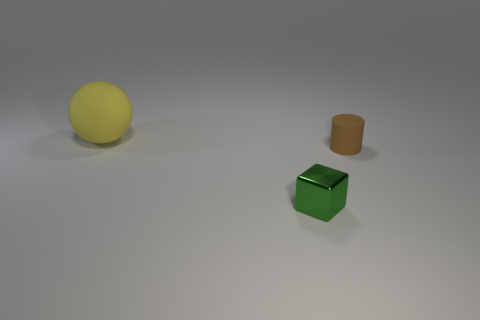Is there any other thing that has the same shape as the tiny matte object?
Give a very brief answer. No. There is a matte object to the right of the green object; how big is it?
Provide a short and direct response. Small. The thing in front of the tiny object behind the small object that is to the left of the tiny brown object is made of what material?
Ensure brevity in your answer.  Metal. Is there a metal cube of the same size as the cylinder?
Make the answer very short. Yes. There is a brown cylinder that is the same size as the metal object; what is it made of?
Provide a succinct answer. Rubber. There is a rubber thing that is right of the yellow ball; what shape is it?
Give a very brief answer. Cylinder. Does the small object that is behind the small metallic block have the same material as the cube that is in front of the tiny brown rubber object?
Your answer should be very brief. No. How many objects are either cyan blocks or matte things left of the tiny brown rubber thing?
Make the answer very short. 1. What material is the green cube?
Provide a succinct answer. Metal. There is a thing that is in front of the matte object that is right of the small metallic object; what color is it?
Offer a terse response. Green. 